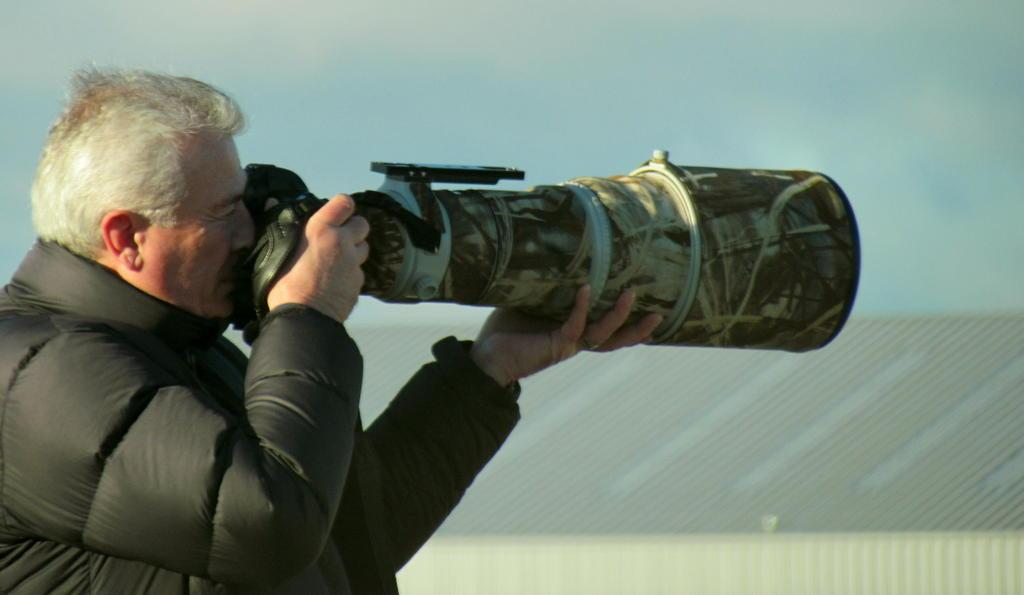Who is present in the image? There is a man in the image. What is the man wearing? The man is wearing a black jacket. What is the man doing in the image? The man is standing and holding a camera. What can be seen in the background of the image? There is a building in the background of the image. What is visible at the top of the image? The sky is visible at the top of the image. What type of jar is the man holding in the image? There is no jar present in the image; the man is holding a camera. Can you see an airplane in the image? No, there is no airplane visible in the image. 